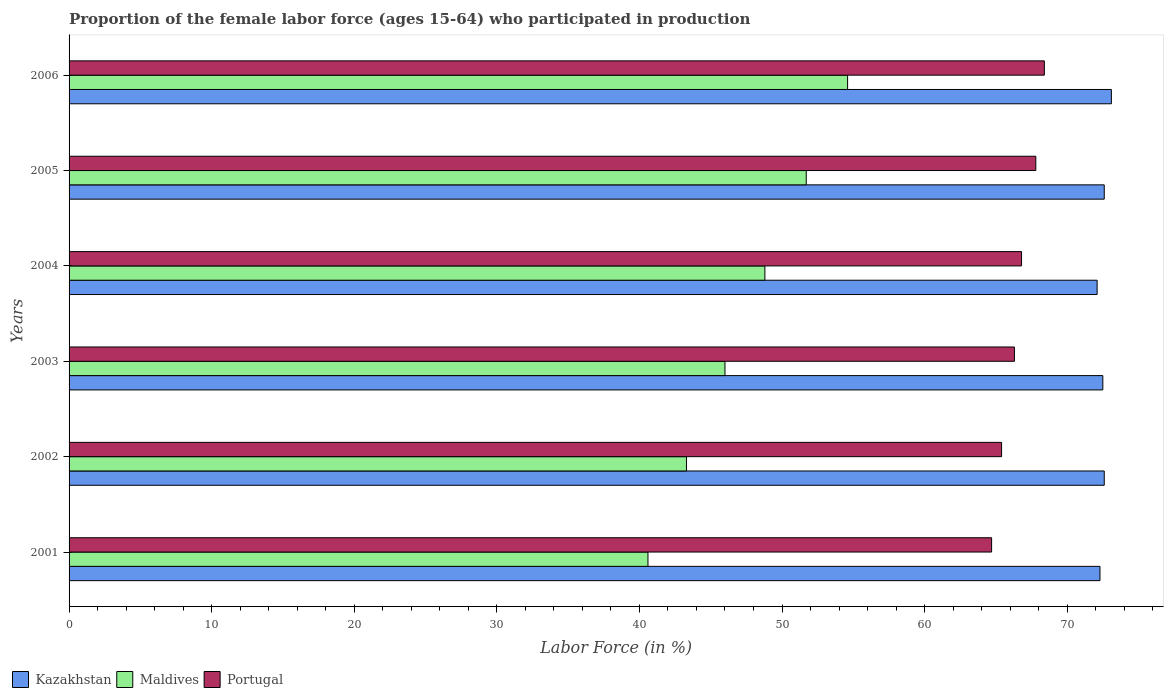How many different coloured bars are there?
Your answer should be compact. 3. Are the number of bars on each tick of the Y-axis equal?
Your answer should be very brief. Yes. How many bars are there on the 4th tick from the top?
Your answer should be very brief. 3. In how many cases, is the number of bars for a given year not equal to the number of legend labels?
Give a very brief answer. 0. What is the proportion of the female labor force who participated in production in Kazakhstan in 2002?
Keep it short and to the point. 72.6. Across all years, what is the maximum proportion of the female labor force who participated in production in Kazakhstan?
Keep it short and to the point. 73.1. Across all years, what is the minimum proportion of the female labor force who participated in production in Portugal?
Offer a very short reply. 64.7. What is the total proportion of the female labor force who participated in production in Kazakhstan in the graph?
Make the answer very short. 435.2. What is the difference between the proportion of the female labor force who participated in production in Portugal in 2001 and that in 2003?
Keep it short and to the point. -1.6. What is the difference between the proportion of the female labor force who participated in production in Kazakhstan in 2001 and the proportion of the female labor force who participated in production in Portugal in 2002?
Your response must be concise. 6.9. What is the average proportion of the female labor force who participated in production in Kazakhstan per year?
Provide a succinct answer. 72.53. In the year 2001, what is the difference between the proportion of the female labor force who participated in production in Maldives and proportion of the female labor force who participated in production in Portugal?
Provide a short and direct response. -24.1. What is the ratio of the proportion of the female labor force who participated in production in Kazakhstan in 2001 to that in 2006?
Offer a terse response. 0.99. What is the difference between the highest and the second highest proportion of the female labor force who participated in production in Maldives?
Your answer should be very brief. 2.9. What is the difference between the highest and the lowest proportion of the female labor force who participated in production in Portugal?
Make the answer very short. 3.7. What does the 3rd bar from the top in 2002 represents?
Keep it short and to the point. Kazakhstan. What does the 2nd bar from the bottom in 2002 represents?
Make the answer very short. Maldives. Is it the case that in every year, the sum of the proportion of the female labor force who participated in production in Maldives and proportion of the female labor force who participated in production in Kazakhstan is greater than the proportion of the female labor force who participated in production in Portugal?
Your answer should be very brief. Yes. How many bars are there?
Provide a short and direct response. 18. Are all the bars in the graph horizontal?
Give a very brief answer. Yes. How many years are there in the graph?
Your answer should be compact. 6. Does the graph contain any zero values?
Make the answer very short. No. Where does the legend appear in the graph?
Your answer should be compact. Bottom left. How are the legend labels stacked?
Make the answer very short. Horizontal. What is the title of the graph?
Your response must be concise. Proportion of the female labor force (ages 15-64) who participated in production. Does "Cameroon" appear as one of the legend labels in the graph?
Give a very brief answer. No. What is the label or title of the X-axis?
Offer a very short reply. Labor Force (in %). What is the label or title of the Y-axis?
Make the answer very short. Years. What is the Labor Force (in %) of Kazakhstan in 2001?
Offer a terse response. 72.3. What is the Labor Force (in %) in Maldives in 2001?
Offer a terse response. 40.6. What is the Labor Force (in %) in Portugal in 2001?
Provide a short and direct response. 64.7. What is the Labor Force (in %) in Kazakhstan in 2002?
Give a very brief answer. 72.6. What is the Labor Force (in %) of Maldives in 2002?
Keep it short and to the point. 43.3. What is the Labor Force (in %) in Portugal in 2002?
Provide a succinct answer. 65.4. What is the Labor Force (in %) of Kazakhstan in 2003?
Keep it short and to the point. 72.5. What is the Labor Force (in %) of Maldives in 2003?
Ensure brevity in your answer.  46. What is the Labor Force (in %) in Portugal in 2003?
Provide a succinct answer. 66.3. What is the Labor Force (in %) of Kazakhstan in 2004?
Offer a very short reply. 72.1. What is the Labor Force (in %) of Maldives in 2004?
Provide a succinct answer. 48.8. What is the Labor Force (in %) of Portugal in 2004?
Your response must be concise. 66.8. What is the Labor Force (in %) in Kazakhstan in 2005?
Give a very brief answer. 72.6. What is the Labor Force (in %) of Maldives in 2005?
Give a very brief answer. 51.7. What is the Labor Force (in %) in Portugal in 2005?
Your response must be concise. 67.8. What is the Labor Force (in %) of Kazakhstan in 2006?
Offer a very short reply. 73.1. What is the Labor Force (in %) in Maldives in 2006?
Give a very brief answer. 54.6. What is the Labor Force (in %) of Portugal in 2006?
Provide a succinct answer. 68.4. Across all years, what is the maximum Labor Force (in %) of Kazakhstan?
Your answer should be compact. 73.1. Across all years, what is the maximum Labor Force (in %) in Maldives?
Keep it short and to the point. 54.6. Across all years, what is the maximum Labor Force (in %) of Portugal?
Your answer should be compact. 68.4. Across all years, what is the minimum Labor Force (in %) in Kazakhstan?
Your response must be concise. 72.1. Across all years, what is the minimum Labor Force (in %) in Maldives?
Your answer should be very brief. 40.6. Across all years, what is the minimum Labor Force (in %) of Portugal?
Your response must be concise. 64.7. What is the total Labor Force (in %) of Kazakhstan in the graph?
Your answer should be very brief. 435.2. What is the total Labor Force (in %) in Maldives in the graph?
Offer a very short reply. 285. What is the total Labor Force (in %) of Portugal in the graph?
Provide a short and direct response. 399.4. What is the difference between the Labor Force (in %) of Kazakhstan in 2001 and that in 2004?
Keep it short and to the point. 0.2. What is the difference between the Labor Force (in %) in Maldives in 2001 and that in 2004?
Offer a terse response. -8.2. What is the difference between the Labor Force (in %) in Portugal in 2001 and that in 2004?
Offer a terse response. -2.1. What is the difference between the Labor Force (in %) in Maldives in 2001 and that in 2005?
Offer a terse response. -11.1. What is the difference between the Labor Force (in %) in Kazakhstan in 2001 and that in 2006?
Your answer should be very brief. -0.8. What is the difference between the Labor Force (in %) of Kazakhstan in 2002 and that in 2003?
Your answer should be very brief. 0.1. What is the difference between the Labor Force (in %) of Maldives in 2002 and that in 2003?
Offer a very short reply. -2.7. What is the difference between the Labor Force (in %) in Kazakhstan in 2002 and that in 2004?
Provide a short and direct response. 0.5. What is the difference between the Labor Force (in %) of Maldives in 2002 and that in 2004?
Ensure brevity in your answer.  -5.5. What is the difference between the Labor Force (in %) in Portugal in 2002 and that in 2005?
Offer a very short reply. -2.4. What is the difference between the Labor Force (in %) of Maldives in 2002 and that in 2006?
Your answer should be very brief. -11.3. What is the difference between the Labor Force (in %) in Maldives in 2003 and that in 2004?
Your answer should be very brief. -2.8. What is the difference between the Labor Force (in %) in Kazakhstan in 2003 and that in 2005?
Provide a short and direct response. -0.1. What is the difference between the Labor Force (in %) of Maldives in 2003 and that in 2005?
Offer a terse response. -5.7. What is the difference between the Labor Force (in %) in Kazakhstan in 2003 and that in 2006?
Your answer should be very brief. -0.6. What is the difference between the Labor Force (in %) in Maldives in 2003 and that in 2006?
Provide a short and direct response. -8.6. What is the difference between the Labor Force (in %) of Maldives in 2004 and that in 2005?
Give a very brief answer. -2.9. What is the difference between the Labor Force (in %) in Portugal in 2004 and that in 2005?
Offer a terse response. -1. What is the difference between the Labor Force (in %) of Kazakhstan in 2004 and that in 2006?
Offer a terse response. -1. What is the difference between the Labor Force (in %) of Maldives in 2004 and that in 2006?
Offer a terse response. -5.8. What is the difference between the Labor Force (in %) of Portugal in 2004 and that in 2006?
Your answer should be compact. -1.6. What is the difference between the Labor Force (in %) in Kazakhstan in 2005 and that in 2006?
Offer a very short reply. -0.5. What is the difference between the Labor Force (in %) in Maldives in 2005 and that in 2006?
Give a very brief answer. -2.9. What is the difference between the Labor Force (in %) in Kazakhstan in 2001 and the Labor Force (in %) in Maldives in 2002?
Offer a terse response. 29. What is the difference between the Labor Force (in %) of Kazakhstan in 2001 and the Labor Force (in %) of Portugal in 2002?
Provide a succinct answer. 6.9. What is the difference between the Labor Force (in %) of Maldives in 2001 and the Labor Force (in %) of Portugal in 2002?
Your answer should be very brief. -24.8. What is the difference between the Labor Force (in %) in Kazakhstan in 2001 and the Labor Force (in %) in Maldives in 2003?
Offer a very short reply. 26.3. What is the difference between the Labor Force (in %) of Kazakhstan in 2001 and the Labor Force (in %) of Portugal in 2003?
Your response must be concise. 6. What is the difference between the Labor Force (in %) in Maldives in 2001 and the Labor Force (in %) in Portugal in 2003?
Give a very brief answer. -25.7. What is the difference between the Labor Force (in %) of Kazakhstan in 2001 and the Labor Force (in %) of Maldives in 2004?
Your answer should be very brief. 23.5. What is the difference between the Labor Force (in %) of Maldives in 2001 and the Labor Force (in %) of Portugal in 2004?
Provide a succinct answer. -26.2. What is the difference between the Labor Force (in %) in Kazakhstan in 2001 and the Labor Force (in %) in Maldives in 2005?
Provide a short and direct response. 20.6. What is the difference between the Labor Force (in %) in Kazakhstan in 2001 and the Labor Force (in %) in Portugal in 2005?
Give a very brief answer. 4.5. What is the difference between the Labor Force (in %) in Maldives in 2001 and the Labor Force (in %) in Portugal in 2005?
Your answer should be very brief. -27.2. What is the difference between the Labor Force (in %) of Maldives in 2001 and the Labor Force (in %) of Portugal in 2006?
Provide a short and direct response. -27.8. What is the difference between the Labor Force (in %) in Kazakhstan in 2002 and the Labor Force (in %) in Maldives in 2003?
Offer a terse response. 26.6. What is the difference between the Labor Force (in %) in Maldives in 2002 and the Labor Force (in %) in Portugal in 2003?
Give a very brief answer. -23. What is the difference between the Labor Force (in %) of Kazakhstan in 2002 and the Labor Force (in %) of Maldives in 2004?
Ensure brevity in your answer.  23.8. What is the difference between the Labor Force (in %) in Maldives in 2002 and the Labor Force (in %) in Portugal in 2004?
Your response must be concise. -23.5. What is the difference between the Labor Force (in %) in Kazakhstan in 2002 and the Labor Force (in %) in Maldives in 2005?
Your answer should be very brief. 20.9. What is the difference between the Labor Force (in %) of Maldives in 2002 and the Labor Force (in %) of Portugal in 2005?
Your response must be concise. -24.5. What is the difference between the Labor Force (in %) of Maldives in 2002 and the Labor Force (in %) of Portugal in 2006?
Give a very brief answer. -25.1. What is the difference between the Labor Force (in %) in Kazakhstan in 2003 and the Labor Force (in %) in Maldives in 2004?
Provide a short and direct response. 23.7. What is the difference between the Labor Force (in %) in Kazakhstan in 2003 and the Labor Force (in %) in Portugal in 2004?
Provide a succinct answer. 5.7. What is the difference between the Labor Force (in %) in Maldives in 2003 and the Labor Force (in %) in Portugal in 2004?
Offer a very short reply. -20.8. What is the difference between the Labor Force (in %) of Kazakhstan in 2003 and the Labor Force (in %) of Maldives in 2005?
Ensure brevity in your answer.  20.8. What is the difference between the Labor Force (in %) of Kazakhstan in 2003 and the Labor Force (in %) of Portugal in 2005?
Provide a short and direct response. 4.7. What is the difference between the Labor Force (in %) of Maldives in 2003 and the Labor Force (in %) of Portugal in 2005?
Give a very brief answer. -21.8. What is the difference between the Labor Force (in %) of Kazakhstan in 2003 and the Labor Force (in %) of Maldives in 2006?
Your answer should be compact. 17.9. What is the difference between the Labor Force (in %) in Kazakhstan in 2003 and the Labor Force (in %) in Portugal in 2006?
Your answer should be compact. 4.1. What is the difference between the Labor Force (in %) of Maldives in 2003 and the Labor Force (in %) of Portugal in 2006?
Your answer should be very brief. -22.4. What is the difference between the Labor Force (in %) of Kazakhstan in 2004 and the Labor Force (in %) of Maldives in 2005?
Ensure brevity in your answer.  20.4. What is the difference between the Labor Force (in %) of Maldives in 2004 and the Labor Force (in %) of Portugal in 2005?
Your response must be concise. -19. What is the difference between the Labor Force (in %) in Kazakhstan in 2004 and the Labor Force (in %) in Maldives in 2006?
Your answer should be very brief. 17.5. What is the difference between the Labor Force (in %) of Kazakhstan in 2004 and the Labor Force (in %) of Portugal in 2006?
Your response must be concise. 3.7. What is the difference between the Labor Force (in %) of Maldives in 2004 and the Labor Force (in %) of Portugal in 2006?
Give a very brief answer. -19.6. What is the difference between the Labor Force (in %) of Kazakhstan in 2005 and the Labor Force (in %) of Portugal in 2006?
Your response must be concise. 4.2. What is the difference between the Labor Force (in %) of Maldives in 2005 and the Labor Force (in %) of Portugal in 2006?
Make the answer very short. -16.7. What is the average Labor Force (in %) of Kazakhstan per year?
Keep it short and to the point. 72.53. What is the average Labor Force (in %) in Maldives per year?
Ensure brevity in your answer.  47.5. What is the average Labor Force (in %) of Portugal per year?
Keep it short and to the point. 66.57. In the year 2001, what is the difference between the Labor Force (in %) in Kazakhstan and Labor Force (in %) in Maldives?
Make the answer very short. 31.7. In the year 2001, what is the difference between the Labor Force (in %) of Kazakhstan and Labor Force (in %) of Portugal?
Offer a terse response. 7.6. In the year 2001, what is the difference between the Labor Force (in %) of Maldives and Labor Force (in %) of Portugal?
Your response must be concise. -24.1. In the year 2002, what is the difference between the Labor Force (in %) of Kazakhstan and Labor Force (in %) of Maldives?
Offer a very short reply. 29.3. In the year 2002, what is the difference between the Labor Force (in %) in Maldives and Labor Force (in %) in Portugal?
Ensure brevity in your answer.  -22.1. In the year 2003, what is the difference between the Labor Force (in %) of Maldives and Labor Force (in %) of Portugal?
Give a very brief answer. -20.3. In the year 2004, what is the difference between the Labor Force (in %) of Kazakhstan and Labor Force (in %) of Maldives?
Offer a terse response. 23.3. In the year 2005, what is the difference between the Labor Force (in %) of Kazakhstan and Labor Force (in %) of Maldives?
Offer a terse response. 20.9. In the year 2005, what is the difference between the Labor Force (in %) in Maldives and Labor Force (in %) in Portugal?
Give a very brief answer. -16.1. What is the ratio of the Labor Force (in %) in Maldives in 2001 to that in 2002?
Offer a very short reply. 0.94. What is the ratio of the Labor Force (in %) of Portugal in 2001 to that in 2002?
Give a very brief answer. 0.99. What is the ratio of the Labor Force (in %) in Maldives in 2001 to that in 2003?
Provide a succinct answer. 0.88. What is the ratio of the Labor Force (in %) in Portugal in 2001 to that in 2003?
Your response must be concise. 0.98. What is the ratio of the Labor Force (in %) in Maldives in 2001 to that in 2004?
Provide a succinct answer. 0.83. What is the ratio of the Labor Force (in %) of Portugal in 2001 to that in 2004?
Make the answer very short. 0.97. What is the ratio of the Labor Force (in %) of Maldives in 2001 to that in 2005?
Your answer should be compact. 0.79. What is the ratio of the Labor Force (in %) of Portugal in 2001 to that in 2005?
Your response must be concise. 0.95. What is the ratio of the Labor Force (in %) in Kazakhstan in 2001 to that in 2006?
Offer a very short reply. 0.99. What is the ratio of the Labor Force (in %) in Maldives in 2001 to that in 2006?
Offer a very short reply. 0.74. What is the ratio of the Labor Force (in %) in Portugal in 2001 to that in 2006?
Offer a very short reply. 0.95. What is the ratio of the Labor Force (in %) of Maldives in 2002 to that in 2003?
Your answer should be very brief. 0.94. What is the ratio of the Labor Force (in %) of Portugal in 2002 to that in 2003?
Provide a succinct answer. 0.99. What is the ratio of the Labor Force (in %) of Maldives in 2002 to that in 2004?
Make the answer very short. 0.89. What is the ratio of the Labor Force (in %) of Portugal in 2002 to that in 2004?
Offer a terse response. 0.98. What is the ratio of the Labor Force (in %) of Maldives in 2002 to that in 2005?
Offer a terse response. 0.84. What is the ratio of the Labor Force (in %) of Portugal in 2002 to that in 2005?
Provide a succinct answer. 0.96. What is the ratio of the Labor Force (in %) of Kazakhstan in 2002 to that in 2006?
Your answer should be very brief. 0.99. What is the ratio of the Labor Force (in %) in Maldives in 2002 to that in 2006?
Your response must be concise. 0.79. What is the ratio of the Labor Force (in %) in Portugal in 2002 to that in 2006?
Your answer should be compact. 0.96. What is the ratio of the Labor Force (in %) in Maldives in 2003 to that in 2004?
Keep it short and to the point. 0.94. What is the ratio of the Labor Force (in %) in Portugal in 2003 to that in 2004?
Offer a terse response. 0.99. What is the ratio of the Labor Force (in %) of Maldives in 2003 to that in 2005?
Make the answer very short. 0.89. What is the ratio of the Labor Force (in %) in Portugal in 2003 to that in 2005?
Offer a terse response. 0.98. What is the ratio of the Labor Force (in %) of Maldives in 2003 to that in 2006?
Keep it short and to the point. 0.84. What is the ratio of the Labor Force (in %) of Portugal in 2003 to that in 2006?
Your answer should be compact. 0.97. What is the ratio of the Labor Force (in %) of Maldives in 2004 to that in 2005?
Provide a succinct answer. 0.94. What is the ratio of the Labor Force (in %) in Portugal in 2004 to that in 2005?
Your answer should be very brief. 0.99. What is the ratio of the Labor Force (in %) of Kazakhstan in 2004 to that in 2006?
Give a very brief answer. 0.99. What is the ratio of the Labor Force (in %) of Maldives in 2004 to that in 2006?
Offer a very short reply. 0.89. What is the ratio of the Labor Force (in %) of Portugal in 2004 to that in 2006?
Your response must be concise. 0.98. What is the ratio of the Labor Force (in %) in Kazakhstan in 2005 to that in 2006?
Provide a succinct answer. 0.99. What is the ratio of the Labor Force (in %) in Maldives in 2005 to that in 2006?
Offer a terse response. 0.95. What is the difference between the highest and the second highest Labor Force (in %) of Kazakhstan?
Keep it short and to the point. 0.5. What is the difference between the highest and the second highest Labor Force (in %) in Maldives?
Keep it short and to the point. 2.9. What is the difference between the highest and the second highest Labor Force (in %) of Portugal?
Your answer should be very brief. 0.6. What is the difference between the highest and the lowest Labor Force (in %) in Kazakhstan?
Make the answer very short. 1. What is the difference between the highest and the lowest Labor Force (in %) in Portugal?
Provide a short and direct response. 3.7. 